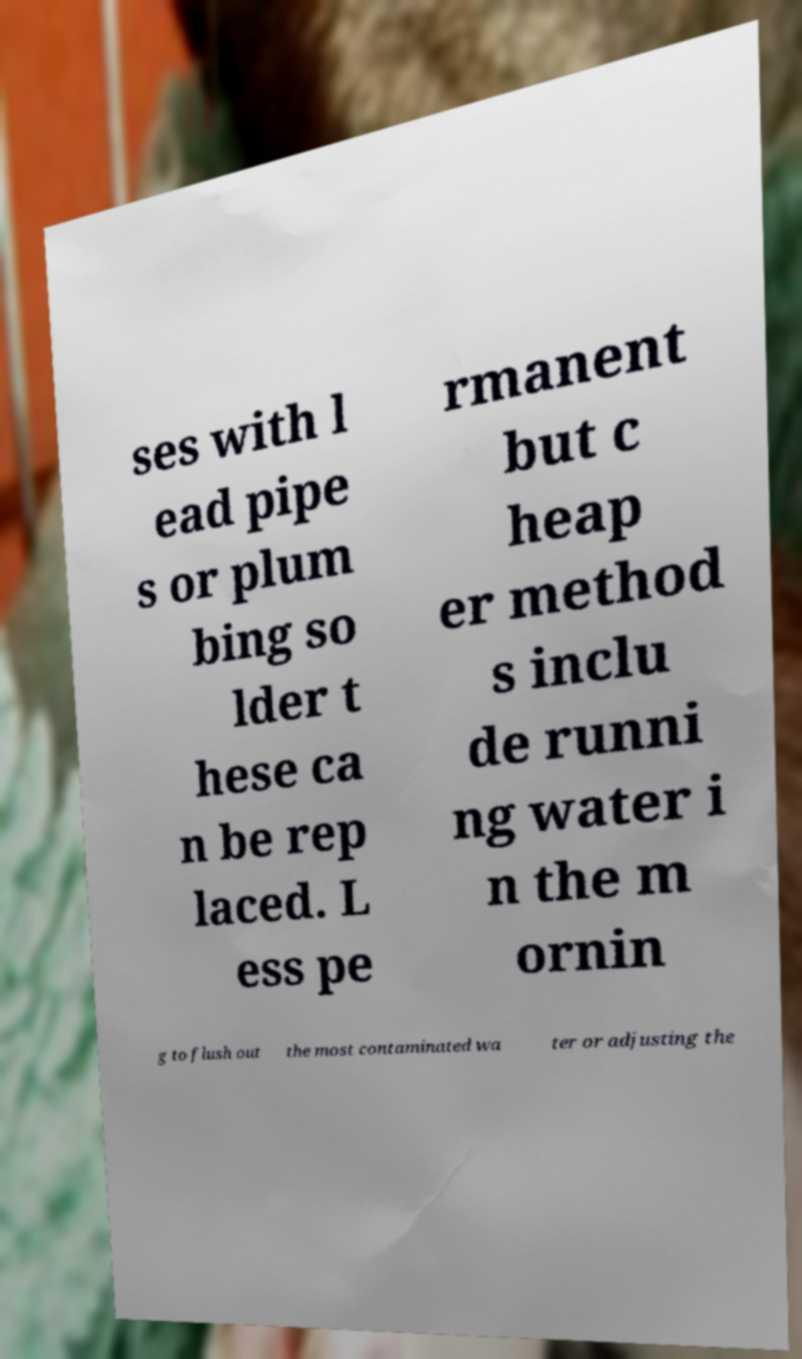Please read and relay the text visible in this image. What does it say? ses with l ead pipe s or plum bing so lder t hese ca n be rep laced. L ess pe rmanent but c heap er method s inclu de runni ng water i n the m ornin g to flush out the most contaminated wa ter or adjusting the 